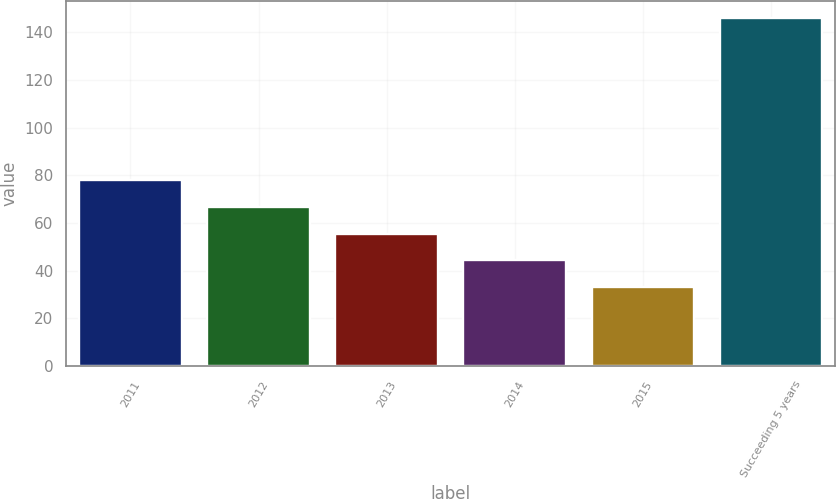Convert chart to OTSL. <chart><loc_0><loc_0><loc_500><loc_500><bar_chart><fcel>2011<fcel>2012<fcel>2013<fcel>2014<fcel>2015<fcel>Succeeding 5 years<nl><fcel>78.16<fcel>66.87<fcel>55.58<fcel>44.29<fcel>33<fcel>145.9<nl></chart> 